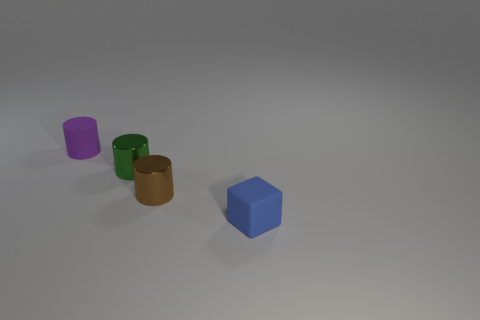How many things are either small yellow shiny spheres or tiny objects?
Ensure brevity in your answer.  4. Is there a tiny brown metal object of the same shape as the tiny green metal object?
Your answer should be very brief. Yes. Does the matte thing that is behind the cube have the same color as the small rubber cube?
Ensure brevity in your answer.  No. What is the shape of the tiny purple rubber thing that is behind the green cylinder behind the brown cylinder?
Your answer should be compact. Cylinder. Is there a yellow cylinder of the same size as the purple rubber thing?
Keep it short and to the point. No. Is the number of tiny blue matte cubes less than the number of large green metal cylinders?
Keep it short and to the point. No. There is a matte thing that is right of the matte object on the left side of the small rubber thing on the right side of the purple cylinder; what shape is it?
Provide a succinct answer. Cube. What number of things are brown cylinders that are to the left of the small blue block or tiny things behind the blue matte block?
Your answer should be compact. 3. There is a purple rubber thing; are there any small blue matte cubes on the left side of it?
Your answer should be very brief. No. What number of objects are metal objects that are on the left side of the brown shiny object or tiny purple things?
Ensure brevity in your answer.  2. 